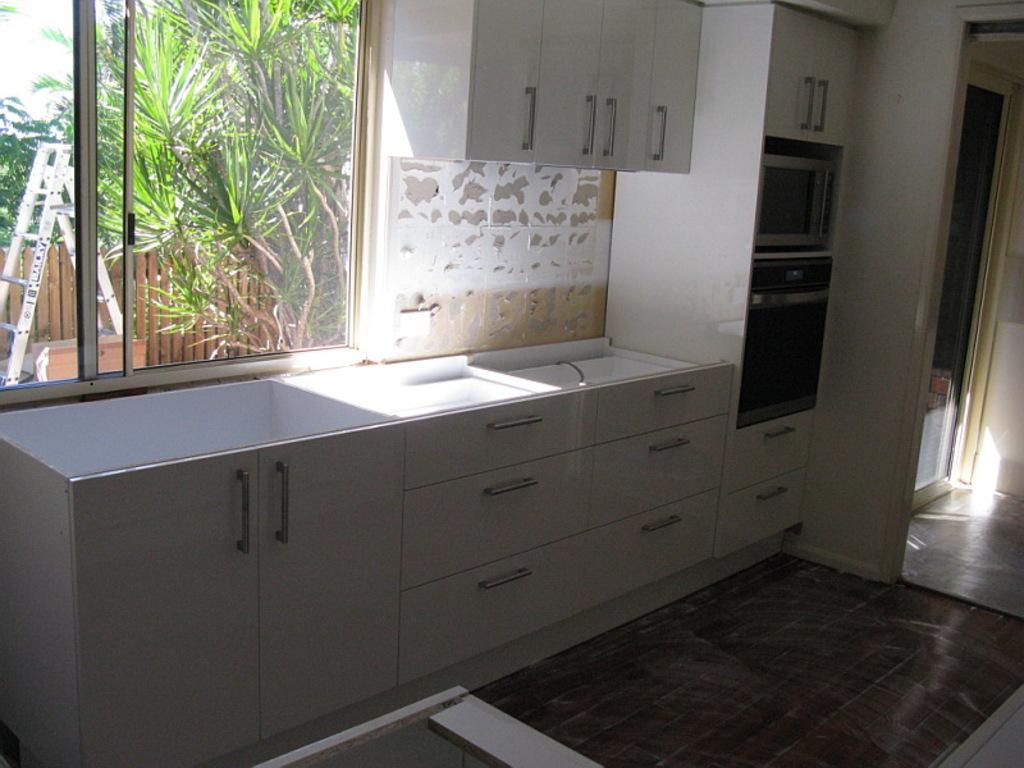What type of furniture is present in the image? There are cupboards and draws in the image. What cooking appliance can be seen on the right side of the image? There is an oven on the right side of the image. What is visible in the background of the image? There is a window in the background. What can be seen outside the window? Trees and a ladder are visible behind the window. Reasoning: Let' Let's think step by step in order to produce the conversation. We start by identifying the main furniture pieces in the image, which are the cupboards and draws. Then, we focus on the cooking appliance, which is the oven. Next, we describe the background of the image, which includes a window. Finally, we mention the specific details that can be seen outside the window, which are the trees and the ladder. Absurd Question/Answer: What type of noise can be heard coming from the pencil in the image? There is no pencil present in the image, so it is not possible to determine any noise associated with it. 